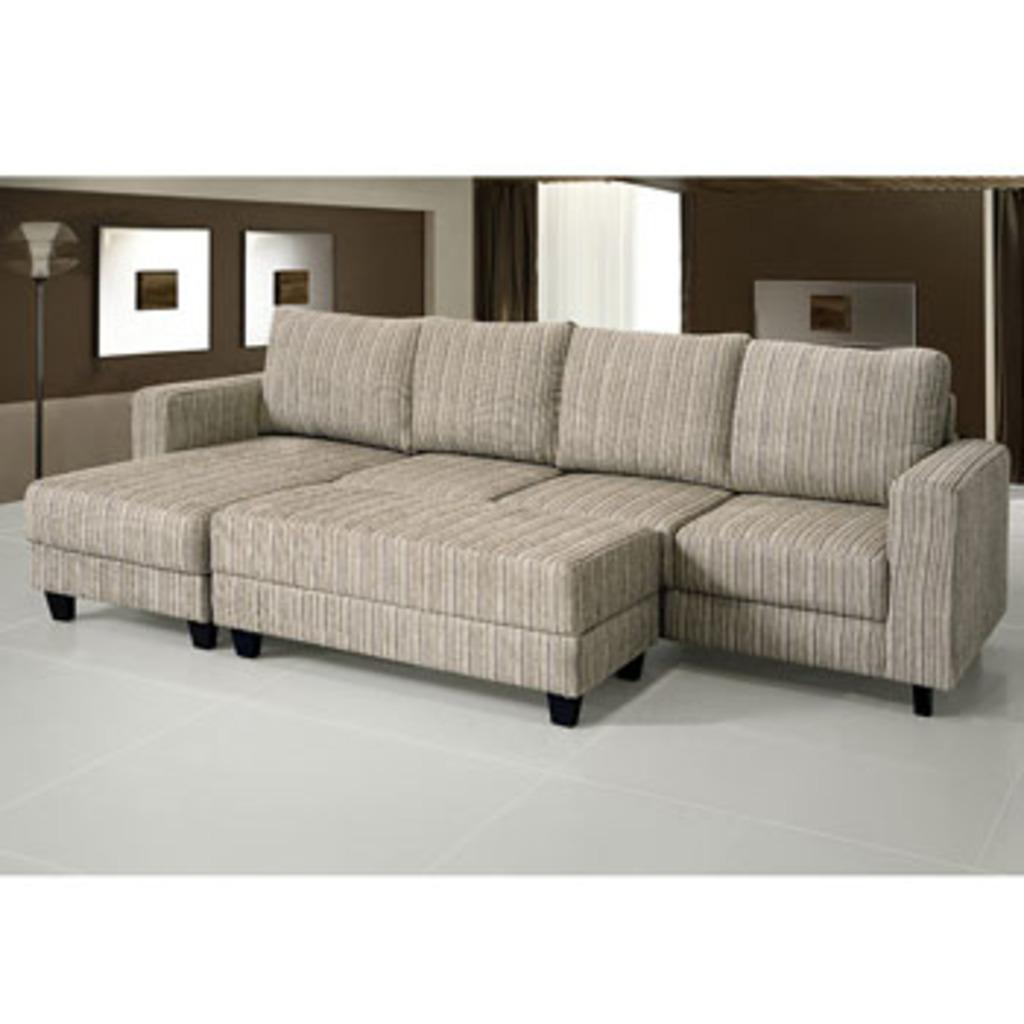What type of furniture is in the room? There is a sofa and chairs in the room. What can be seen on the floor? Chairs are on the floor. What is present in the background of the room? There are curtains and a wall visible in the background. What type of oatmeal is being served in the scene? There is no oatmeal present in the image, as it only features a sofa, chairs, curtains, and a wall. What angle was the image taken from? The angle from which the image was taken is not mentioned in the provided facts, so it cannot be determined. 